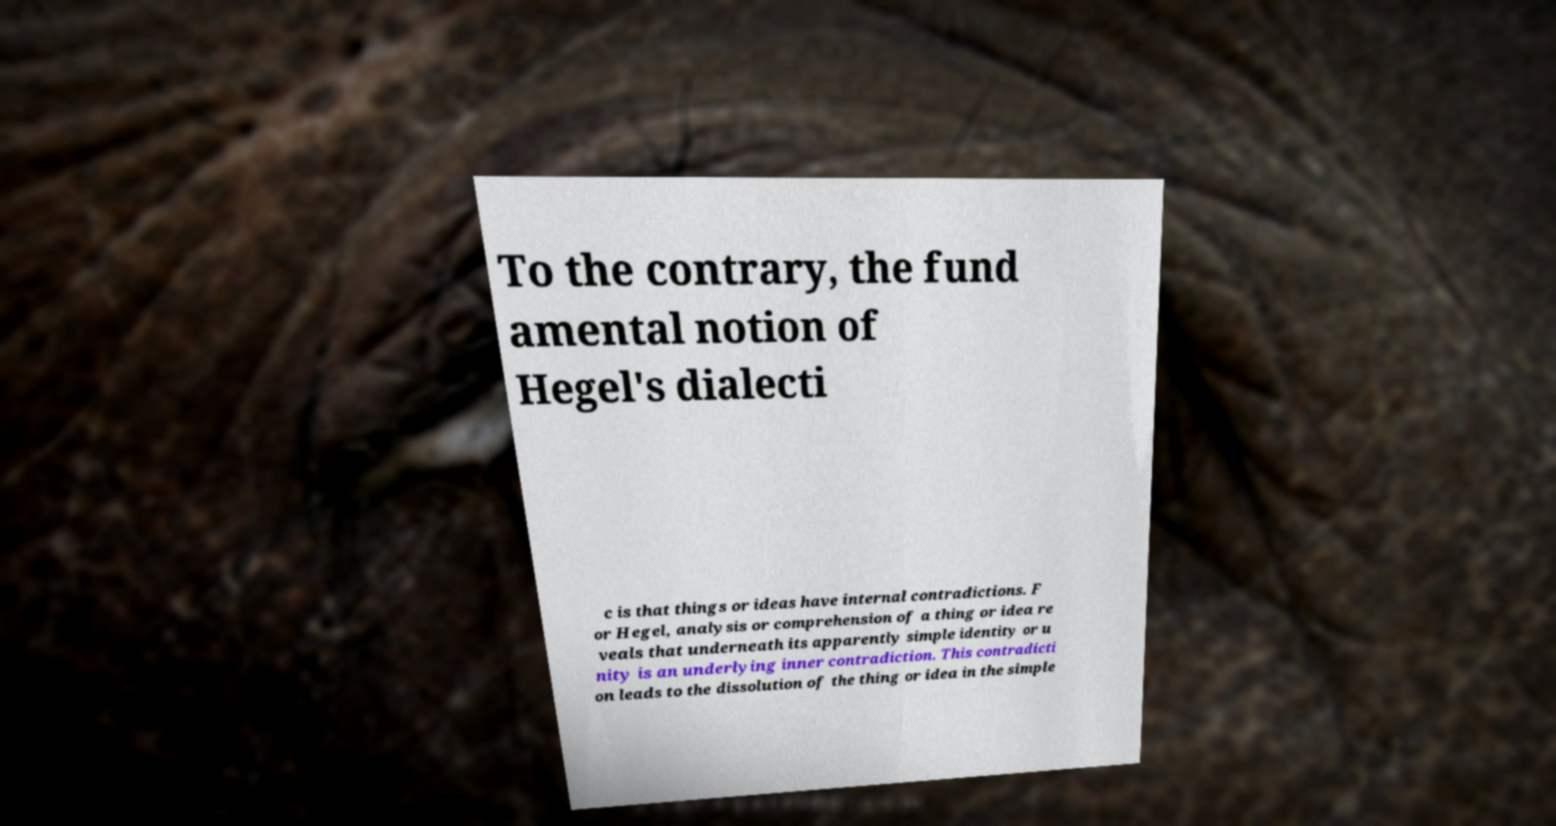There's text embedded in this image that I need extracted. Can you transcribe it verbatim? To the contrary, the fund amental notion of Hegel's dialecti c is that things or ideas have internal contradictions. F or Hegel, analysis or comprehension of a thing or idea re veals that underneath its apparently simple identity or u nity is an underlying inner contradiction. This contradicti on leads to the dissolution of the thing or idea in the simple 